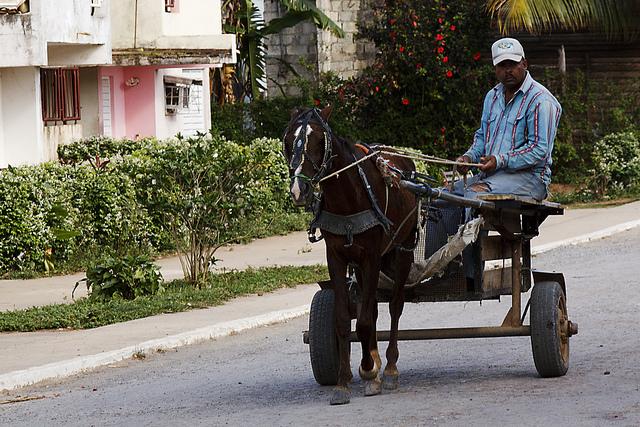Is this in America?
Give a very brief answer. No. Is the man in the picturing wearing a hat?
Write a very short answer. Yes. What type of shrub is on the sidewalk?
Give a very brief answer. Bush. 